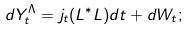<formula> <loc_0><loc_0><loc_500><loc_500>d Y _ { t } ^ { \Lambda } = j _ { t } ( L ^ { * } L ) d t + d W _ { t } ;</formula> 